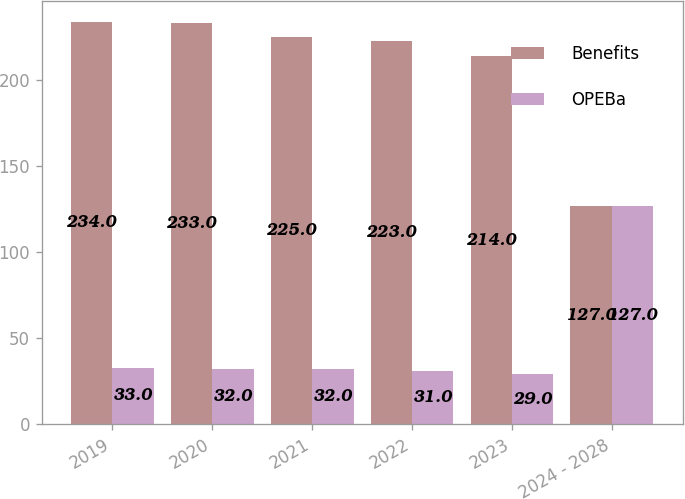Convert chart to OTSL. <chart><loc_0><loc_0><loc_500><loc_500><stacked_bar_chart><ecel><fcel>2019<fcel>2020<fcel>2021<fcel>2022<fcel>2023<fcel>2024 - 2028<nl><fcel>Benefits<fcel>234<fcel>233<fcel>225<fcel>223<fcel>214<fcel>127<nl><fcel>OPEBa<fcel>33<fcel>32<fcel>32<fcel>31<fcel>29<fcel>127<nl></chart> 